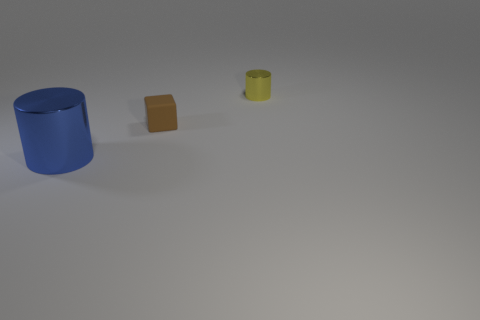What material is the cylinder that is in front of the metallic cylinder that is to the right of the tiny block made of?
Your answer should be compact. Metal. Do the object that is to the left of the brown object and the brown thing have the same shape?
Your answer should be compact. No. There is another large object that is the same material as the yellow object; what color is it?
Your answer should be very brief. Blue. There is a tiny block that is left of the yellow object; what is its material?
Your answer should be very brief. Rubber. There is a tiny yellow thing; is it the same shape as the large metallic object in front of the rubber object?
Ensure brevity in your answer.  Yes. What material is the thing that is right of the large blue thing and on the left side of the small cylinder?
Your answer should be compact. Rubber. The other metal object that is the same size as the brown thing is what color?
Your answer should be very brief. Yellow. Is the material of the blue cylinder the same as the small thing that is in front of the yellow cylinder?
Provide a succinct answer. No. What number of other things are there of the same size as the block?
Offer a terse response. 1. Is there a brown thing that is on the right side of the metal object that is left of the metallic cylinder that is behind the large shiny cylinder?
Make the answer very short. Yes. 